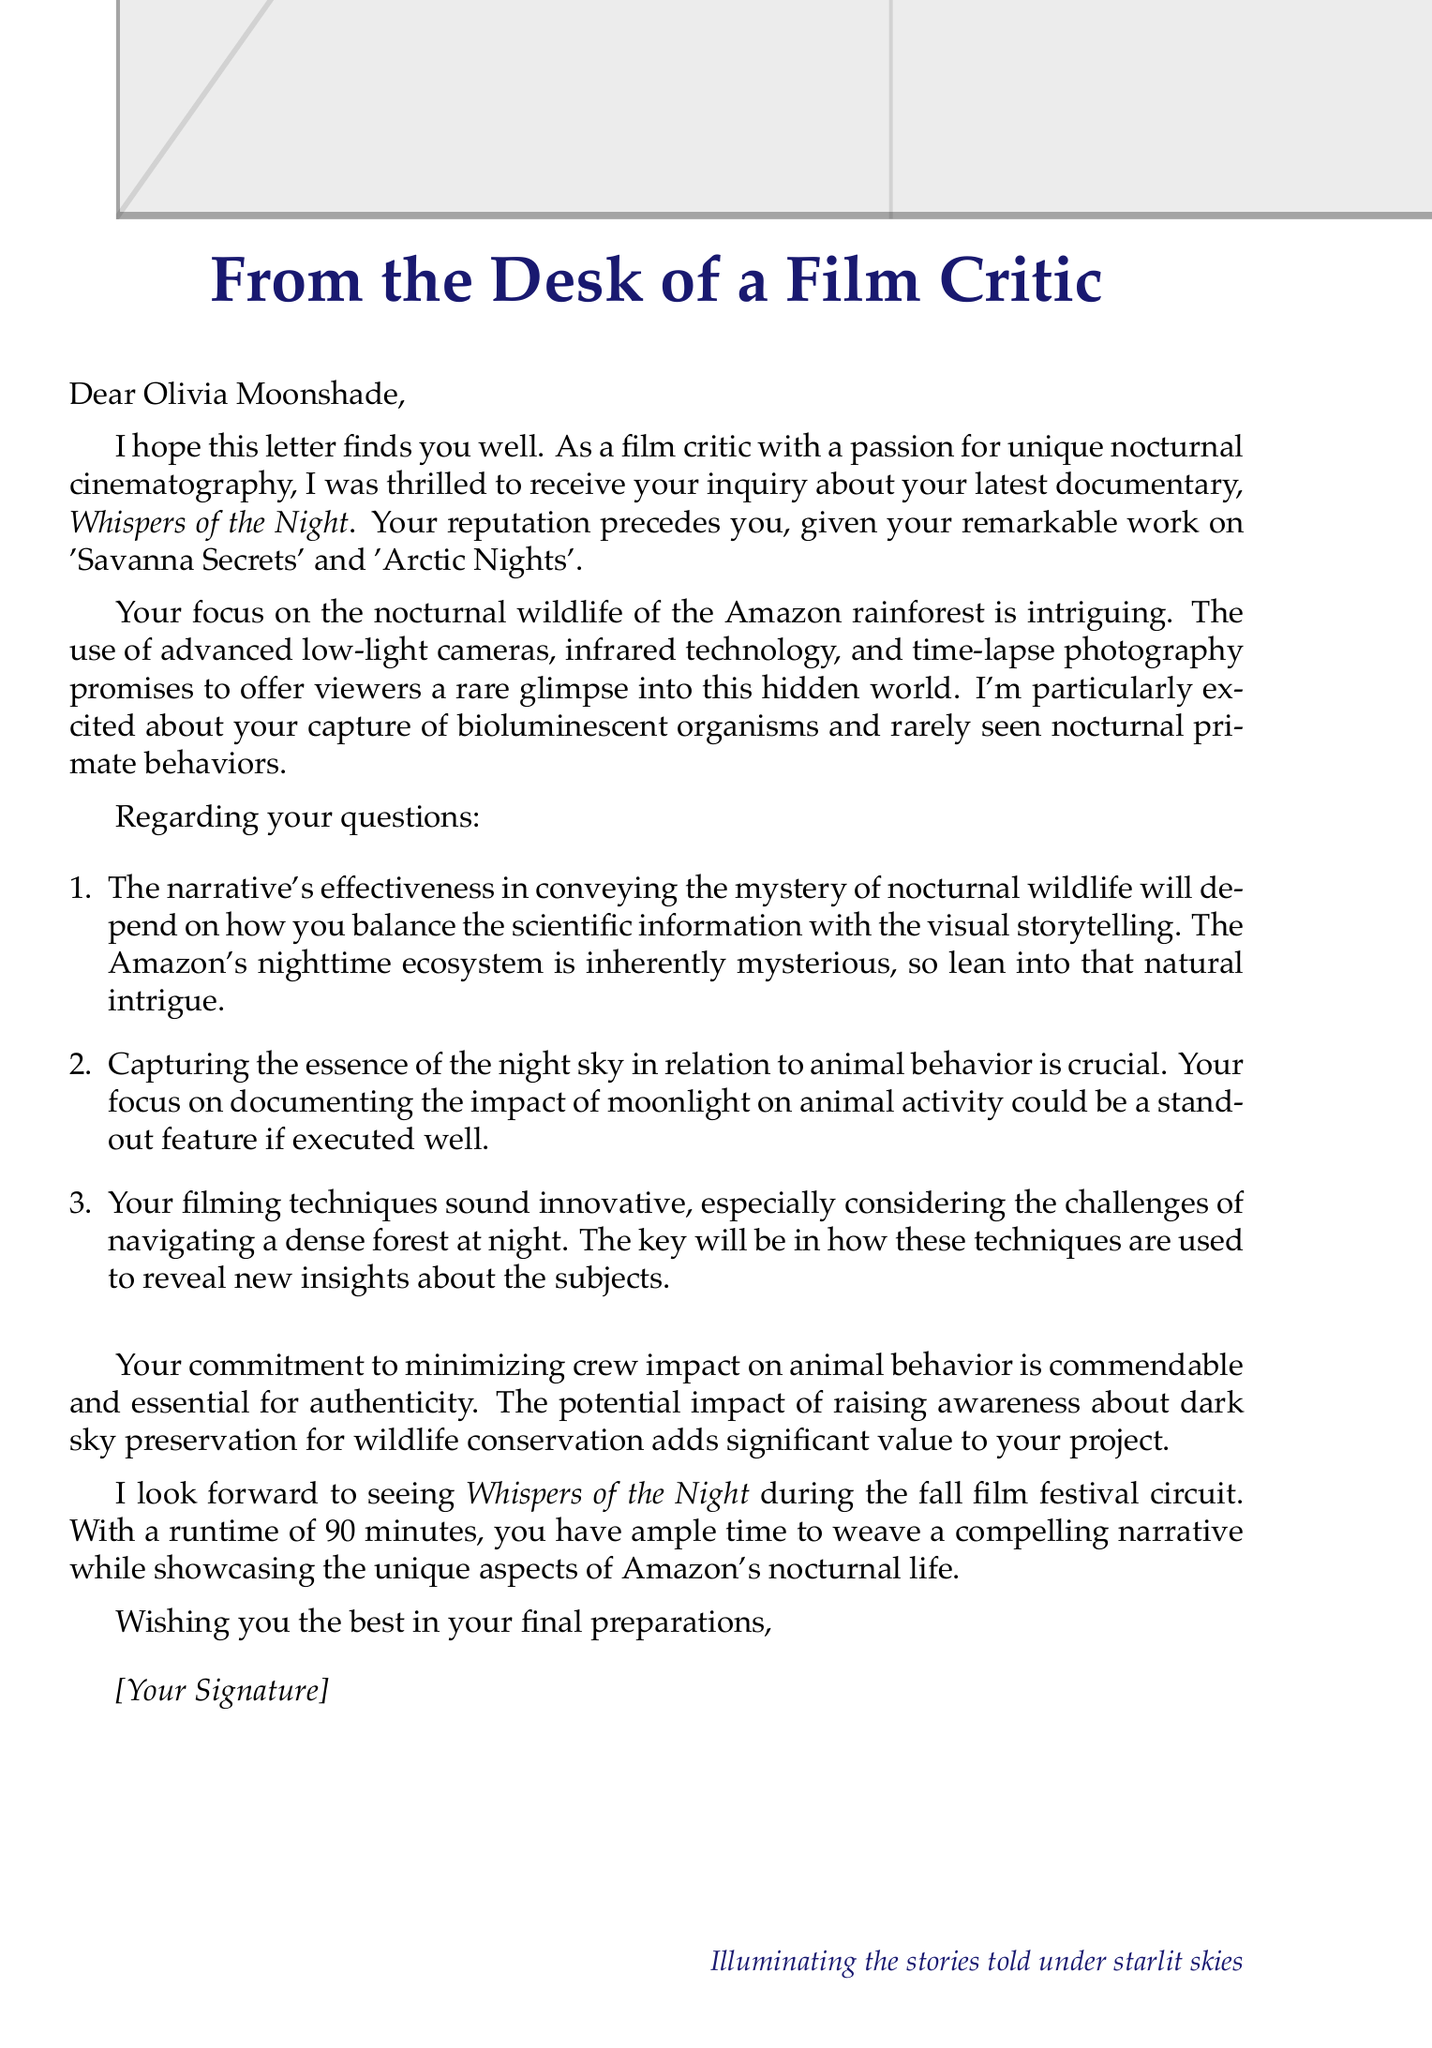What is the title of the documentary? The title of the documentary is mentioned at the beginning of the letter.
Answer: Whispers of the Night Who is the filmmaker? The document states the name of the filmmaker in the salutation.
Answer: Olivia Moonshade What is the runtime of the documentary? The runtime is specified in the details provided in the document.
Answer: 90 minutes What are the filming techniques used in the documentary? A list of filming techniques is provided in the document, highlighting new technologies.
Answer: Advanced low-light cameras, infrared technology, time-lapse photography What is the focus of the documentary? The document details the specific wildlife theme addressed in the film.
Answer: Nocturnal wildlife in the Amazon rainforest Which unique aspect involves animal behavior? The unique aspects section includes specific behavioral captures related to animals.
Answer: Recording rarely seen nocturnal primate behaviors What is the potential impact of the documentary? The document mentions a significant social aspect tied to the documentary's goals.
Answer: Raising awareness about the importance of preserving dark skies for wildlife conservation What is one challenge faced during filming? The document lists challenges, indicating obstacles encountered while filming.
Answer: Navigating dense forest at night What is the filmmaker looking for feedback on? The questions posed by the filmmaker in the document express their request for critical input.
Answer: Narrative effectiveness, capturing night sky essence, innovative filming techniques 